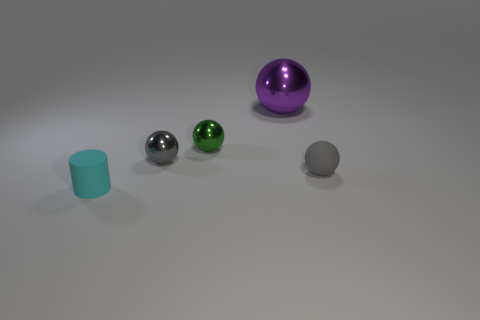Subtract all big purple spheres. How many spheres are left? 3 Subtract all green blocks. How many gray spheres are left? 2 Subtract all purple balls. How many balls are left? 3 Add 5 big blue metal blocks. How many objects exist? 10 Add 5 gray things. How many gray things are left? 7 Add 2 large yellow metal blocks. How many large yellow metal blocks exist? 2 Subtract 0 green cubes. How many objects are left? 5 Subtract all cylinders. How many objects are left? 4 Subtract all green balls. Subtract all purple blocks. How many balls are left? 3 Subtract all tiny green metallic things. Subtract all big shiny things. How many objects are left? 3 